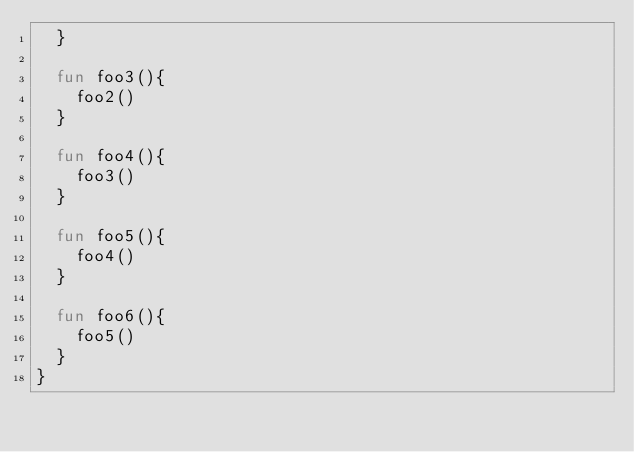<code> <loc_0><loc_0><loc_500><loc_500><_Kotlin_>  }

  fun foo3(){
    foo2()
  }

  fun foo4(){
    foo3()
  }

  fun foo5(){
    foo4()
  }

  fun foo6(){
    foo5()
  }
}</code> 